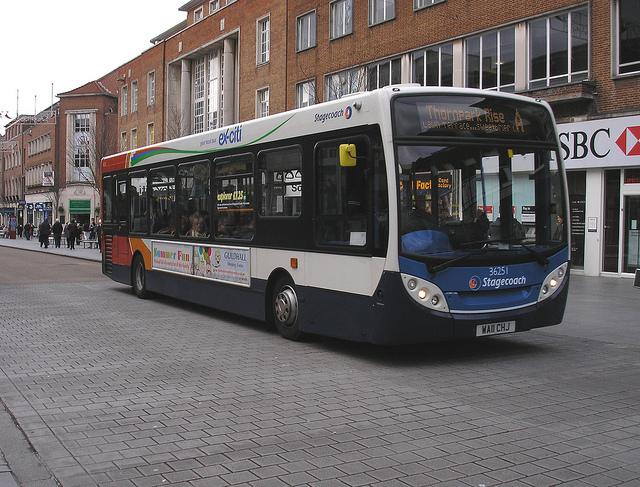Is there any writing on the pavement?
Keep it brief. No. What color is the base of the bus?
Short answer required. Black. How many levels on the bus?
Answer briefly. 1. What is the building made of?
Write a very short answer. Brick. Is the bus double deckered?
Give a very brief answer. No. Does this bus have an advertisement on it?
Keep it brief. Yes. Is this at a bus station?
Keep it brief. No. Is this a single decker bus?
Short answer required. Yes. Is this a double decker bus?
Answer briefly. No. How many buses are there?
Write a very short answer. 1. What is behind the bus on the pavement?
Be succinct. People. How many busses?
Keep it brief. 1. What color is the bus?
Quick response, please. White. What color do the two buses have in common?
Concise answer only. White. What is the first number on the license plate?
Concise answer only. No numbers. Why is the road made of brick?
Write a very short answer. Easy to place. Is this bus a double decker?
Be succinct. No. 